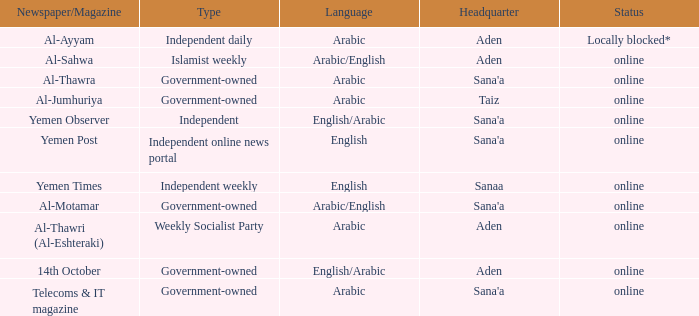Parse the full table. {'header': ['Newspaper/Magazine', 'Type', 'Language', 'Headquarter', 'Status'], 'rows': [['Al-Ayyam', 'Independent daily', 'Arabic', 'Aden', 'Locally blocked*'], ['Al-Sahwa', 'Islamist weekly', 'Arabic/English', 'Aden', 'online'], ['Al-Thawra', 'Government-owned', 'Arabic', "Sana'a", 'online'], ['Al-Jumhuriya', 'Government-owned', 'Arabic', 'Taiz', 'online'], ['Yemen Observer', 'Independent', 'English/Arabic', "Sana'a", 'online'], ['Yemen Post', 'Independent online news portal', 'English', "Sana'a", 'online'], ['Yemen Times', 'Independent weekly', 'English', 'Sanaa', 'online'], ['Al-Motamar', 'Government-owned', 'Arabic/English', "Sana'a", 'online'], ['Al-Thawri (Al-Eshteraki)', 'Weekly Socialist Party', 'Arabic', 'Aden', 'online'], ['14th October', 'Government-owned', 'English/Arabic', 'Aden', 'online'], ['Telecoms & IT magazine', 'Government-owned', 'Arabic', "Sana'a", 'online']]} What is Headquarter, when Language is English, and when Type is Independent Online News Portal? Sana'a. 